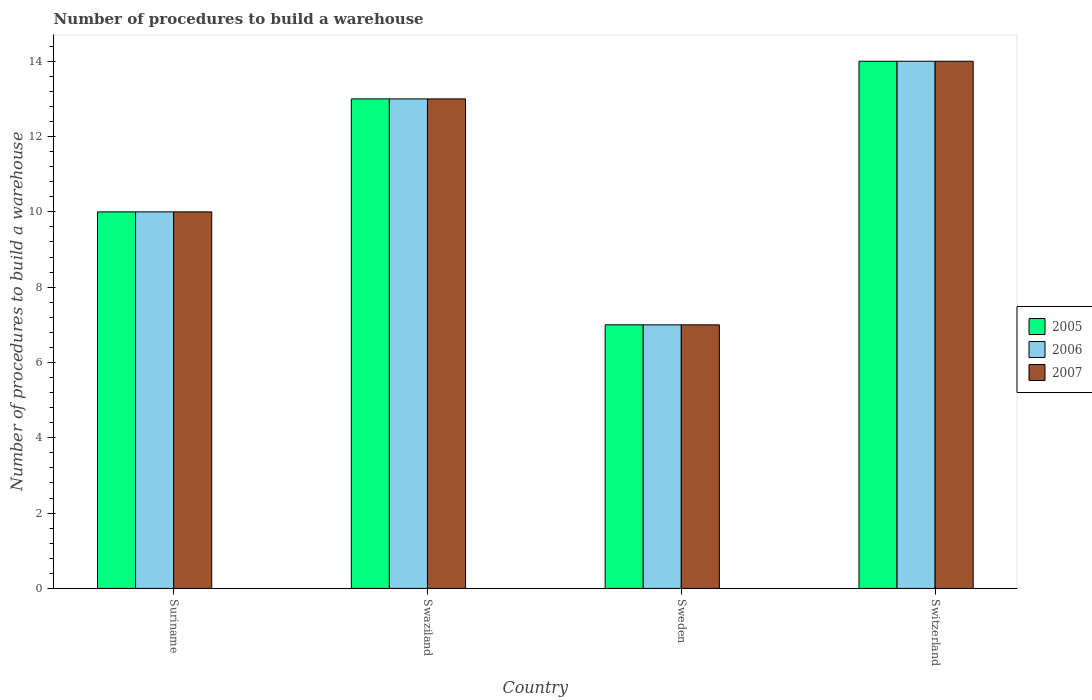How many different coloured bars are there?
Your response must be concise. 3. How many groups of bars are there?
Offer a very short reply. 4. Are the number of bars per tick equal to the number of legend labels?
Provide a short and direct response. Yes. Are the number of bars on each tick of the X-axis equal?
Offer a terse response. Yes. How many bars are there on the 1st tick from the left?
Ensure brevity in your answer.  3. What is the label of the 1st group of bars from the left?
Give a very brief answer. Suriname. What is the number of procedures to build a warehouse in in 2006 in Swaziland?
Offer a terse response. 13. In which country was the number of procedures to build a warehouse in in 2007 maximum?
Provide a succinct answer. Switzerland. In which country was the number of procedures to build a warehouse in in 2005 minimum?
Your response must be concise. Sweden. What is the difference between the number of procedures to build a warehouse in in 2007 in Suriname and that in Sweden?
Offer a terse response. 3. What is the average number of procedures to build a warehouse in in 2006 per country?
Provide a short and direct response. 11. What is the difference between the number of procedures to build a warehouse in of/in 2005 and number of procedures to build a warehouse in of/in 2007 in Switzerland?
Ensure brevity in your answer.  0. Is the number of procedures to build a warehouse in in 2006 in Swaziland less than that in Sweden?
Provide a succinct answer. No. Is the difference between the number of procedures to build a warehouse in in 2005 in Suriname and Switzerland greater than the difference between the number of procedures to build a warehouse in in 2007 in Suriname and Switzerland?
Provide a succinct answer. No. What is the difference between the highest and the second highest number of procedures to build a warehouse in in 2007?
Give a very brief answer. -3. What is the difference between the highest and the lowest number of procedures to build a warehouse in in 2006?
Provide a succinct answer. 7. In how many countries, is the number of procedures to build a warehouse in in 2006 greater than the average number of procedures to build a warehouse in in 2006 taken over all countries?
Keep it short and to the point. 2. What does the 1st bar from the left in Switzerland represents?
Give a very brief answer. 2005. Is it the case that in every country, the sum of the number of procedures to build a warehouse in in 2006 and number of procedures to build a warehouse in in 2007 is greater than the number of procedures to build a warehouse in in 2005?
Provide a succinct answer. Yes. How many bars are there?
Ensure brevity in your answer.  12. Are all the bars in the graph horizontal?
Keep it short and to the point. No. How many countries are there in the graph?
Keep it short and to the point. 4. Does the graph contain any zero values?
Your response must be concise. No. Does the graph contain grids?
Your answer should be compact. No. How many legend labels are there?
Your response must be concise. 3. How are the legend labels stacked?
Provide a short and direct response. Vertical. What is the title of the graph?
Your answer should be compact. Number of procedures to build a warehouse. What is the label or title of the Y-axis?
Your answer should be very brief. Number of procedures to build a warehouse. What is the Number of procedures to build a warehouse of 2005 in Suriname?
Provide a succinct answer. 10. What is the Number of procedures to build a warehouse of 2006 in Suriname?
Provide a short and direct response. 10. What is the Number of procedures to build a warehouse of 2006 in Swaziland?
Your answer should be compact. 13. What is the Number of procedures to build a warehouse of 2007 in Swaziland?
Offer a terse response. 13. What is the Number of procedures to build a warehouse of 2005 in Sweden?
Provide a short and direct response. 7. What is the Number of procedures to build a warehouse of 2006 in Sweden?
Your response must be concise. 7. What is the Number of procedures to build a warehouse of 2005 in Switzerland?
Offer a very short reply. 14. What is the Number of procedures to build a warehouse of 2007 in Switzerland?
Give a very brief answer. 14. Across all countries, what is the minimum Number of procedures to build a warehouse of 2006?
Make the answer very short. 7. What is the total Number of procedures to build a warehouse in 2007 in the graph?
Make the answer very short. 44. What is the difference between the Number of procedures to build a warehouse of 2006 in Suriname and that in Swaziland?
Offer a terse response. -3. What is the difference between the Number of procedures to build a warehouse of 2005 in Suriname and that in Sweden?
Offer a very short reply. 3. What is the difference between the Number of procedures to build a warehouse in 2006 in Suriname and that in Switzerland?
Make the answer very short. -4. What is the difference between the Number of procedures to build a warehouse of 2007 in Suriname and that in Switzerland?
Your answer should be compact. -4. What is the difference between the Number of procedures to build a warehouse of 2005 in Swaziland and that in Sweden?
Offer a terse response. 6. What is the difference between the Number of procedures to build a warehouse of 2006 in Swaziland and that in Sweden?
Offer a terse response. 6. What is the difference between the Number of procedures to build a warehouse of 2007 in Swaziland and that in Sweden?
Offer a very short reply. 6. What is the difference between the Number of procedures to build a warehouse of 2005 in Swaziland and that in Switzerland?
Provide a short and direct response. -1. What is the difference between the Number of procedures to build a warehouse in 2006 in Swaziland and that in Switzerland?
Your response must be concise. -1. What is the difference between the Number of procedures to build a warehouse of 2007 in Swaziland and that in Switzerland?
Your answer should be very brief. -1. What is the difference between the Number of procedures to build a warehouse in 2005 in Sweden and that in Switzerland?
Offer a very short reply. -7. What is the difference between the Number of procedures to build a warehouse of 2007 in Sweden and that in Switzerland?
Keep it short and to the point. -7. What is the difference between the Number of procedures to build a warehouse in 2005 in Suriname and the Number of procedures to build a warehouse in 2006 in Swaziland?
Provide a short and direct response. -3. What is the difference between the Number of procedures to build a warehouse of 2005 in Suriname and the Number of procedures to build a warehouse of 2006 in Sweden?
Your answer should be very brief. 3. What is the difference between the Number of procedures to build a warehouse in 2005 in Suriname and the Number of procedures to build a warehouse in 2007 in Sweden?
Your answer should be very brief. 3. What is the difference between the Number of procedures to build a warehouse of 2005 in Suriname and the Number of procedures to build a warehouse of 2006 in Switzerland?
Keep it short and to the point. -4. What is the difference between the Number of procedures to build a warehouse in 2005 in Swaziland and the Number of procedures to build a warehouse in 2006 in Sweden?
Provide a succinct answer. 6. What is the difference between the Number of procedures to build a warehouse in 2005 in Swaziland and the Number of procedures to build a warehouse in 2006 in Switzerland?
Keep it short and to the point. -1. What is the difference between the Number of procedures to build a warehouse of 2006 in Swaziland and the Number of procedures to build a warehouse of 2007 in Switzerland?
Offer a very short reply. -1. What is the difference between the Number of procedures to build a warehouse in 2005 in Sweden and the Number of procedures to build a warehouse in 2007 in Switzerland?
Your answer should be compact. -7. What is the difference between the Number of procedures to build a warehouse of 2005 and Number of procedures to build a warehouse of 2006 in Suriname?
Offer a terse response. 0. What is the difference between the Number of procedures to build a warehouse of 2006 and Number of procedures to build a warehouse of 2007 in Suriname?
Ensure brevity in your answer.  0. What is the difference between the Number of procedures to build a warehouse in 2005 and Number of procedures to build a warehouse in 2007 in Swaziland?
Your response must be concise. 0. What is the difference between the Number of procedures to build a warehouse of 2005 and Number of procedures to build a warehouse of 2007 in Sweden?
Your answer should be very brief. 0. What is the difference between the Number of procedures to build a warehouse in 2006 and Number of procedures to build a warehouse in 2007 in Sweden?
Ensure brevity in your answer.  0. What is the ratio of the Number of procedures to build a warehouse of 2005 in Suriname to that in Swaziland?
Your answer should be very brief. 0.77. What is the ratio of the Number of procedures to build a warehouse of 2006 in Suriname to that in Swaziland?
Provide a succinct answer. 0.77. What is the ratio of the Number of procedures to build a warehouse in 2007 in Suriname to that in Swaziland?
Ensure brevity in your answer.  0.77. What is the ratio of the Number of procedures to build a warehouse of 2005 in Suriname to that in Sweden?
Give a very brief answer. 1.43. What is the ratio of the Number of procedures to build a warehouse in 2006 in Suriname to that in Sweden?
Make the answer very short. 1.43. What is the ratio of the Number of procedures to build a warehouse in 2007 in Suriname to that in Sweden?
Ensure brevity in your answer.  1.43. What is the ratio of the Number of procedures to build a warehouse in 2005 in Suriname to that in Switzerland?
Your answer should be compact. 0.71. What is the ratio of the Number of procedures to build a warehouse in 2005 in Swaziland to that in Sweden?
Give a very brief answer. 1.86. What is the ratio of the Number of procedures to build a warehouse of 2006 in Swaziland to that in Sweden?
Give a very brief answer. 1.86. What is the ratio of the Number of procedures to build a warehouse of 2007 in Swaziland to that in Sweden?
Keep it short and to the point. 1.86. What is the ratio of the Number of procedures to build a warehouse of 2007 in Swaziland to that in Switzerland?
Make the answer very short. 0.93. What is the ratio of the Number of procedures to build a warehouse in 2007 in Sweden to that in Switzerland?
Offer a very short reply. 0.5. What is the difference between the highest and the second highest Number of procedures to build a warehouse in 2006?
Keep it short and to the point. 1. What is the difference between the highest and the lowest Number of procedures to build a warehouse in 2006?
Offer a very short reply. 7. 